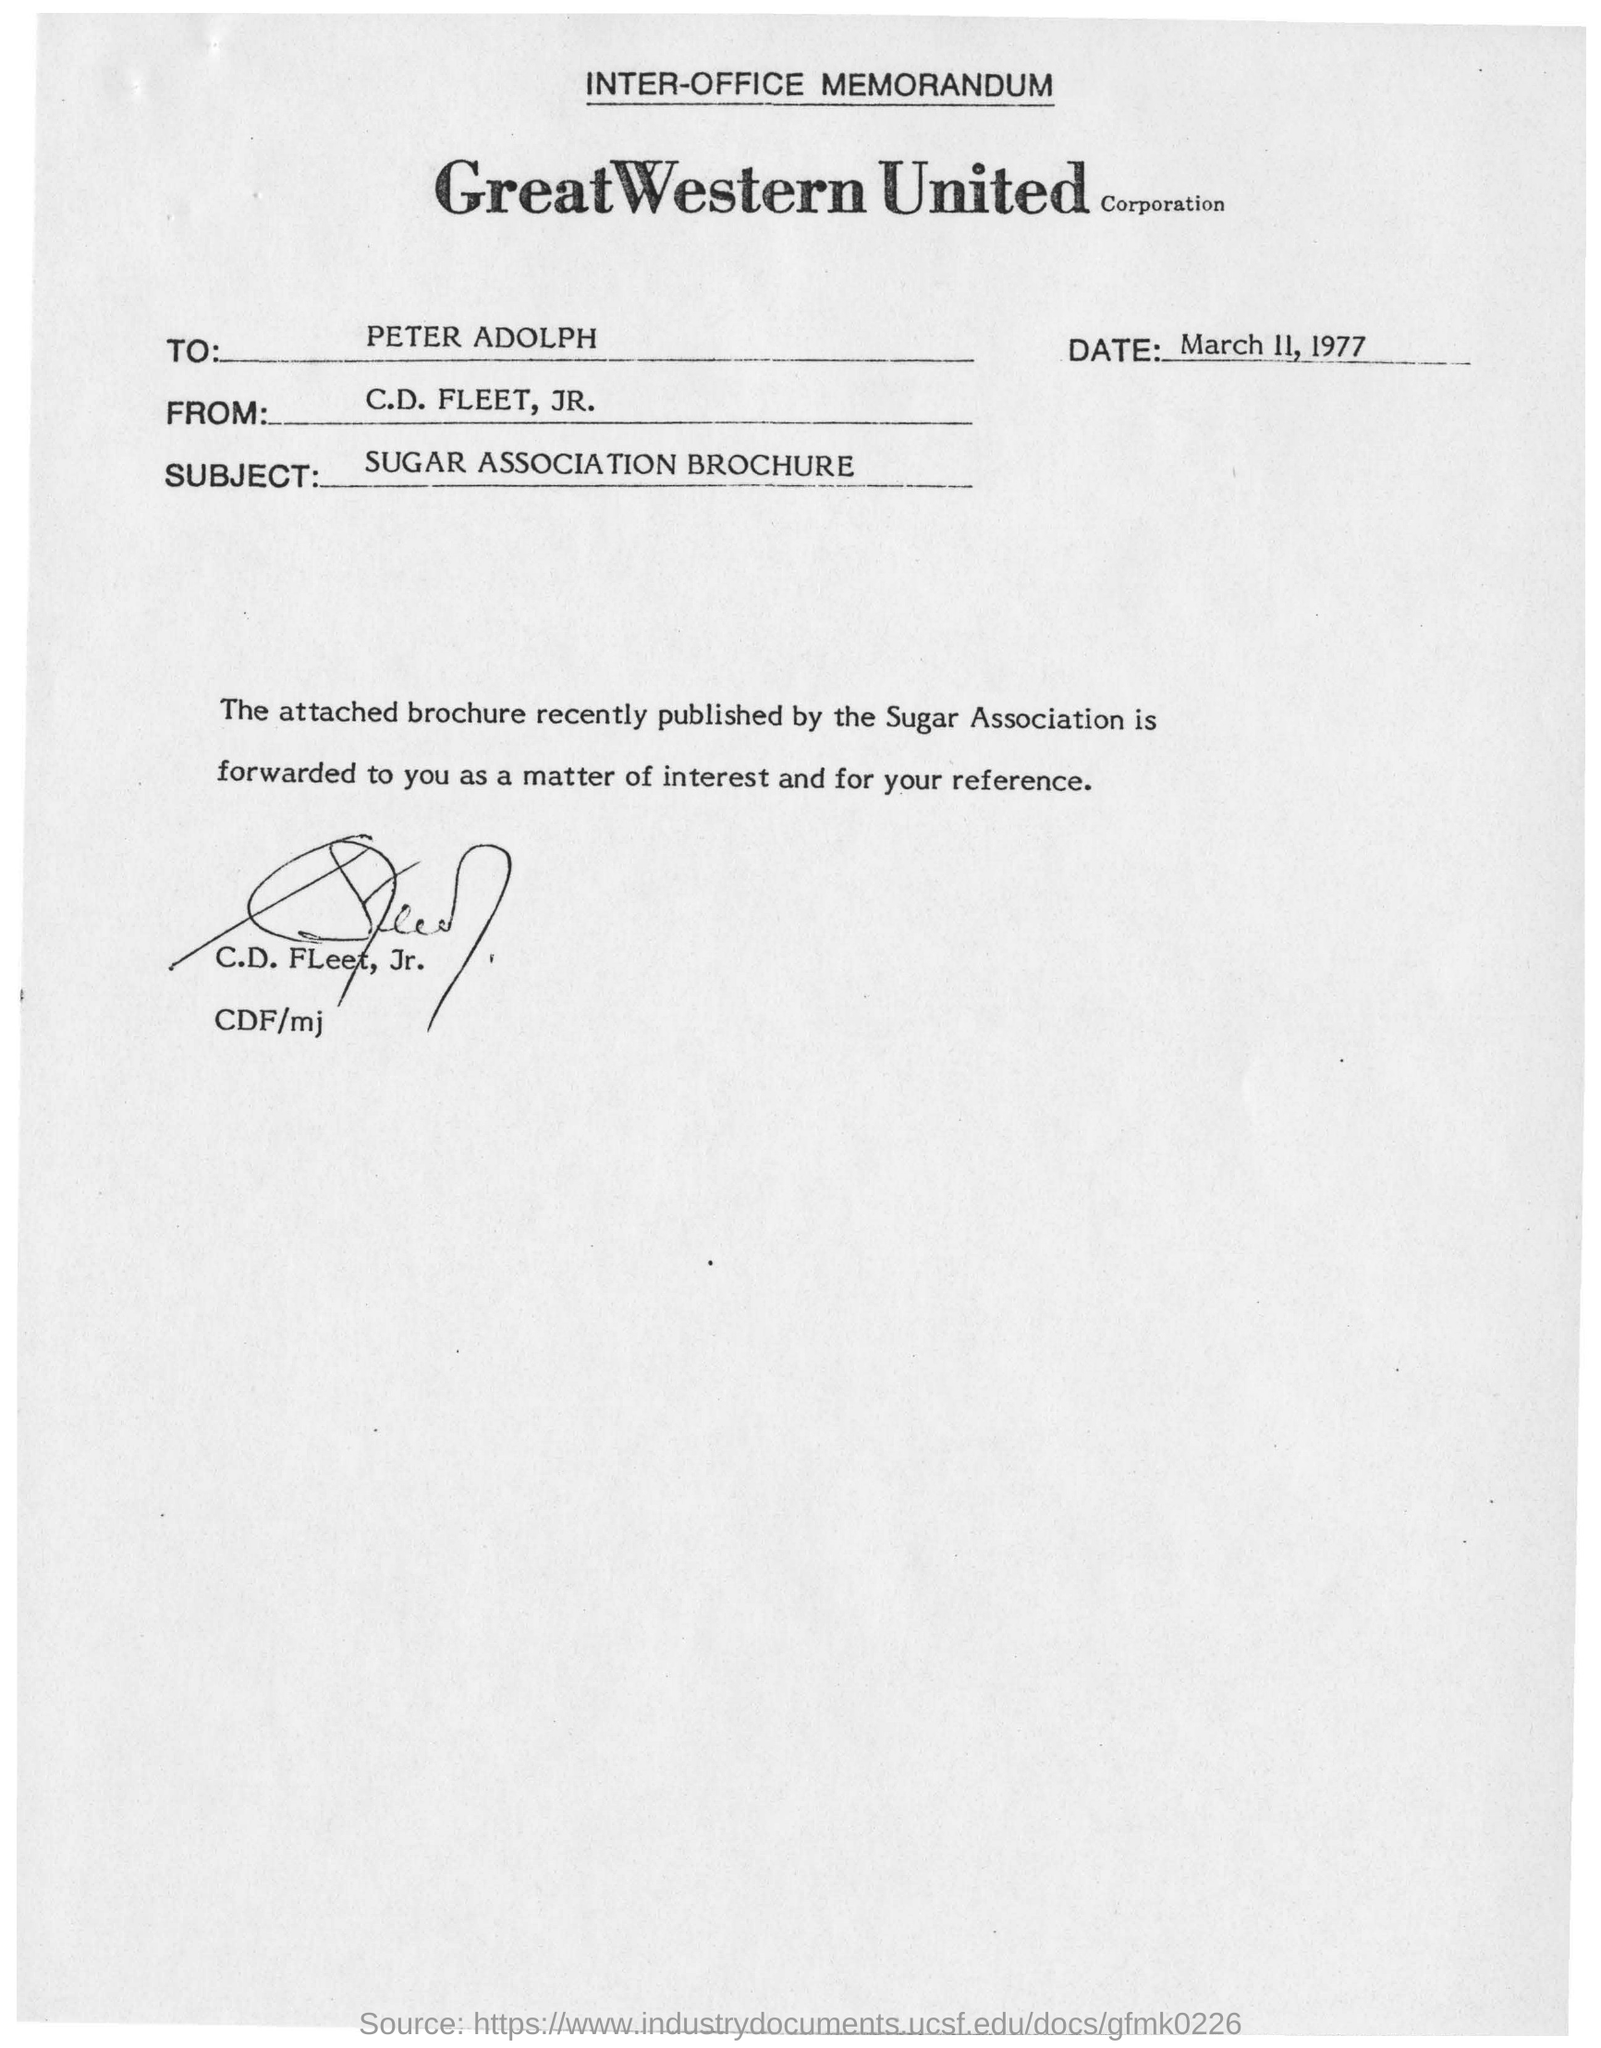Indicate a few pertinent items in this graphic. The memorandum is sent to C.D. Fleet, Jr. The memorandum is addressed to Peter Adolph. The memorandum was dated on March 11, 1977. 